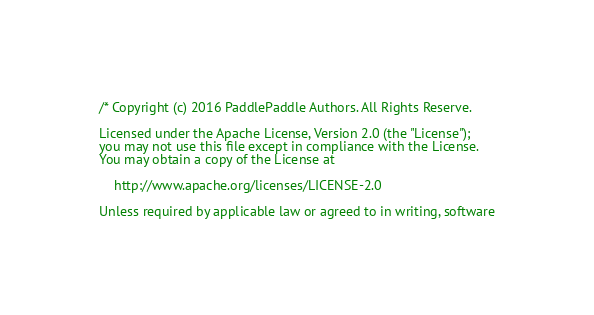Convert code to text. <code><loc_0><loc_0><loc_500><loc_500><_Cuda_>/* Copyright (c) 2016 PaddlePaddle Authors. All Rights Reserve.

Licensed under the Apache License, Version 2.0 (the "License");
you may not use this file except in compliance with the License.
You may obtain a copy of the License at

    http://www.apache.org/licenses/LICENSE-2.0

Unless required by applicable law or agreed to in writing, software</code> 